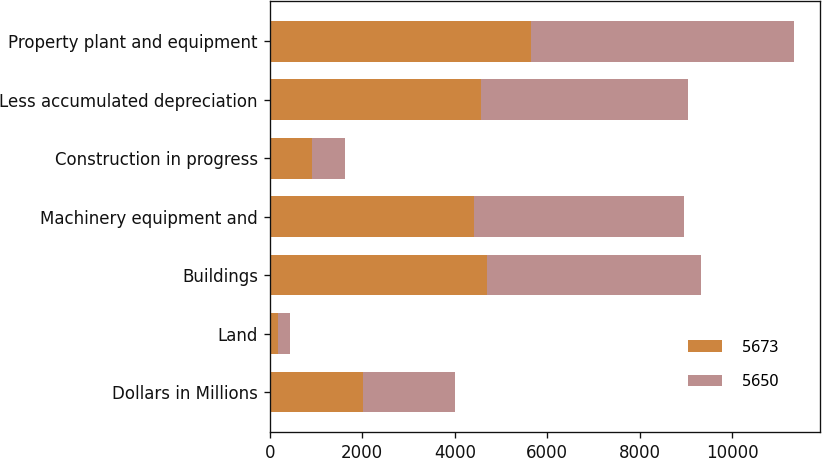Convert chart. <chart><loc_0><loc_0><loc_500><loc_500><stacked_bar_chart><ecel><fcel>Dollars in Millions<fcel>Land<fcel>Buildings<fcel>Machinery equipment and<fcel>Construction in progress<fcel>Less accumulated depreciation<fcel>Property plant and equipment<nl><fcel>5673<fcel>2007<fcel>185<fcel>4696<fcel>4418<fcel>915<fcel>4564<fcel>5650<nl><fcel>5650<fcel>2006<fcel>254<fcel>4630<fcel>4540<fcel>720<fcel>4471<fcel>5673<nl></chart> 